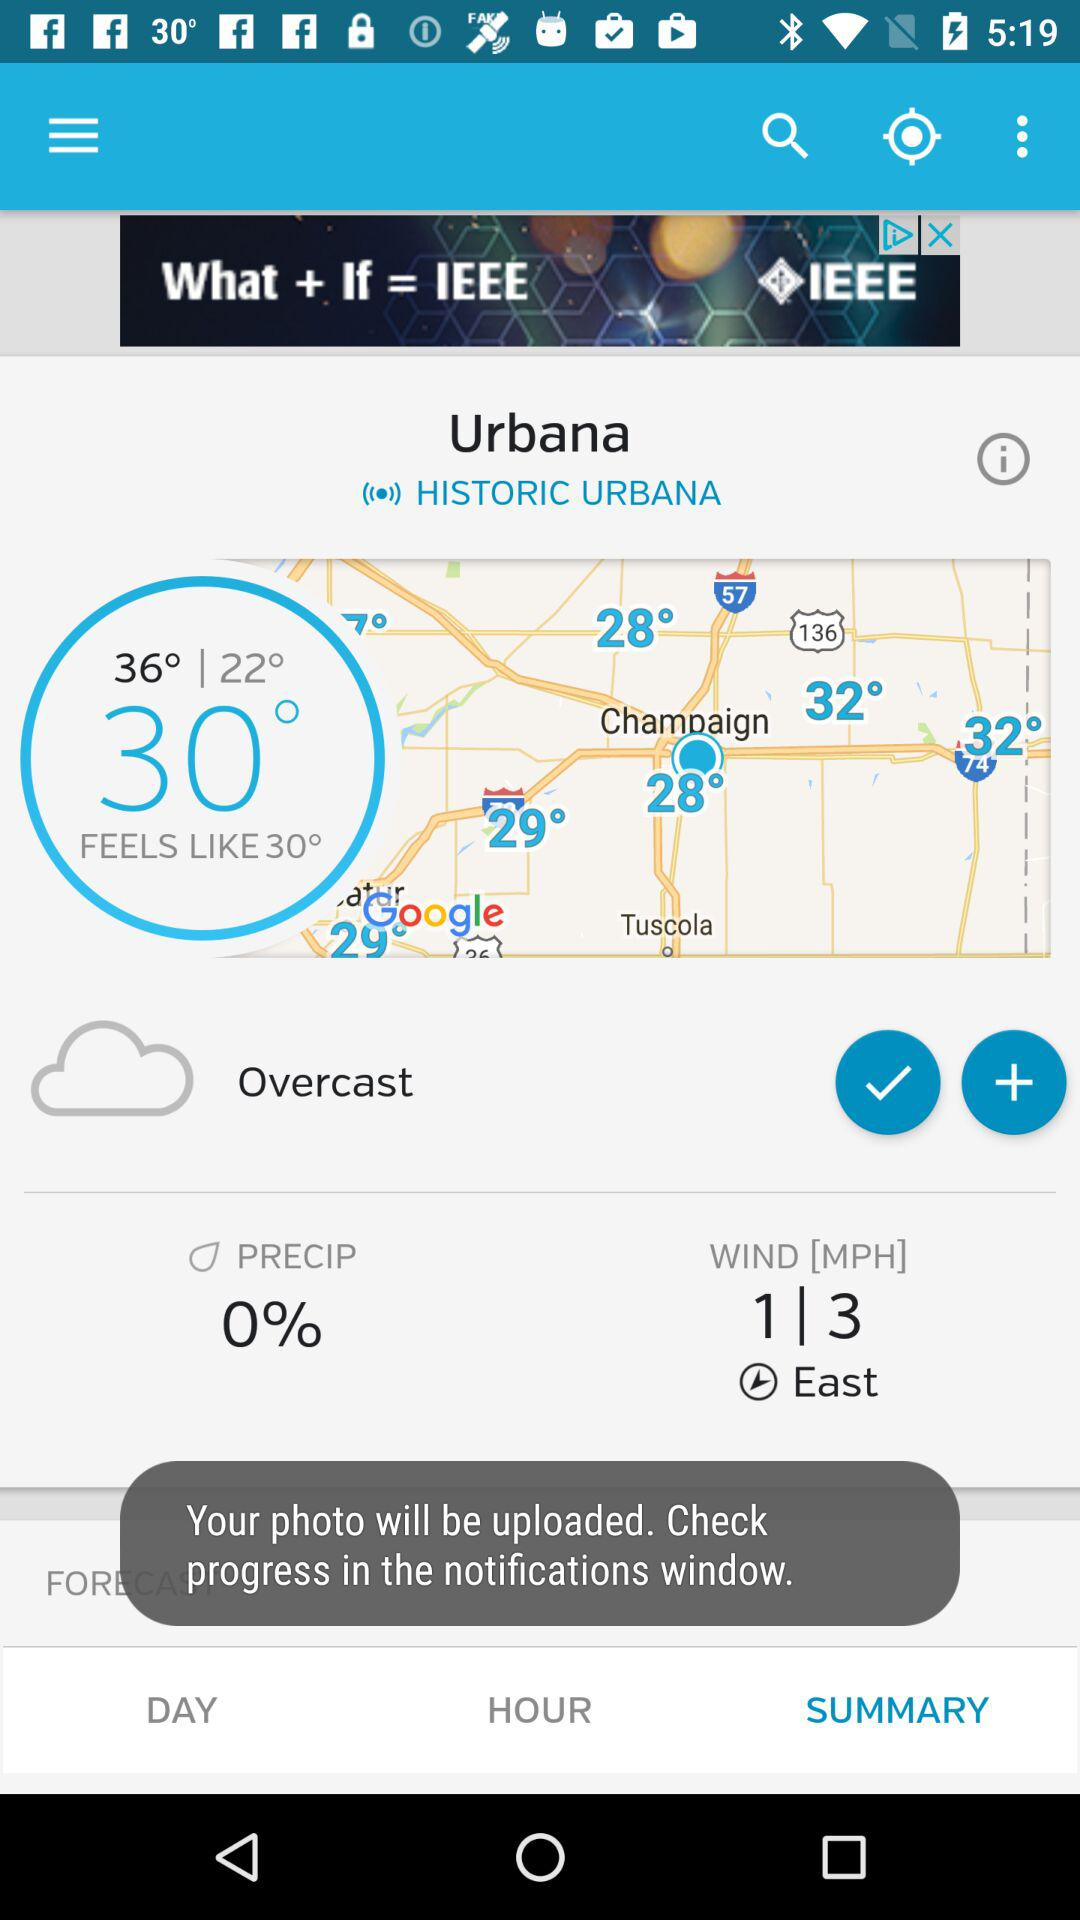What is the wind direction?
Answer the question using a single word or phrase. East 